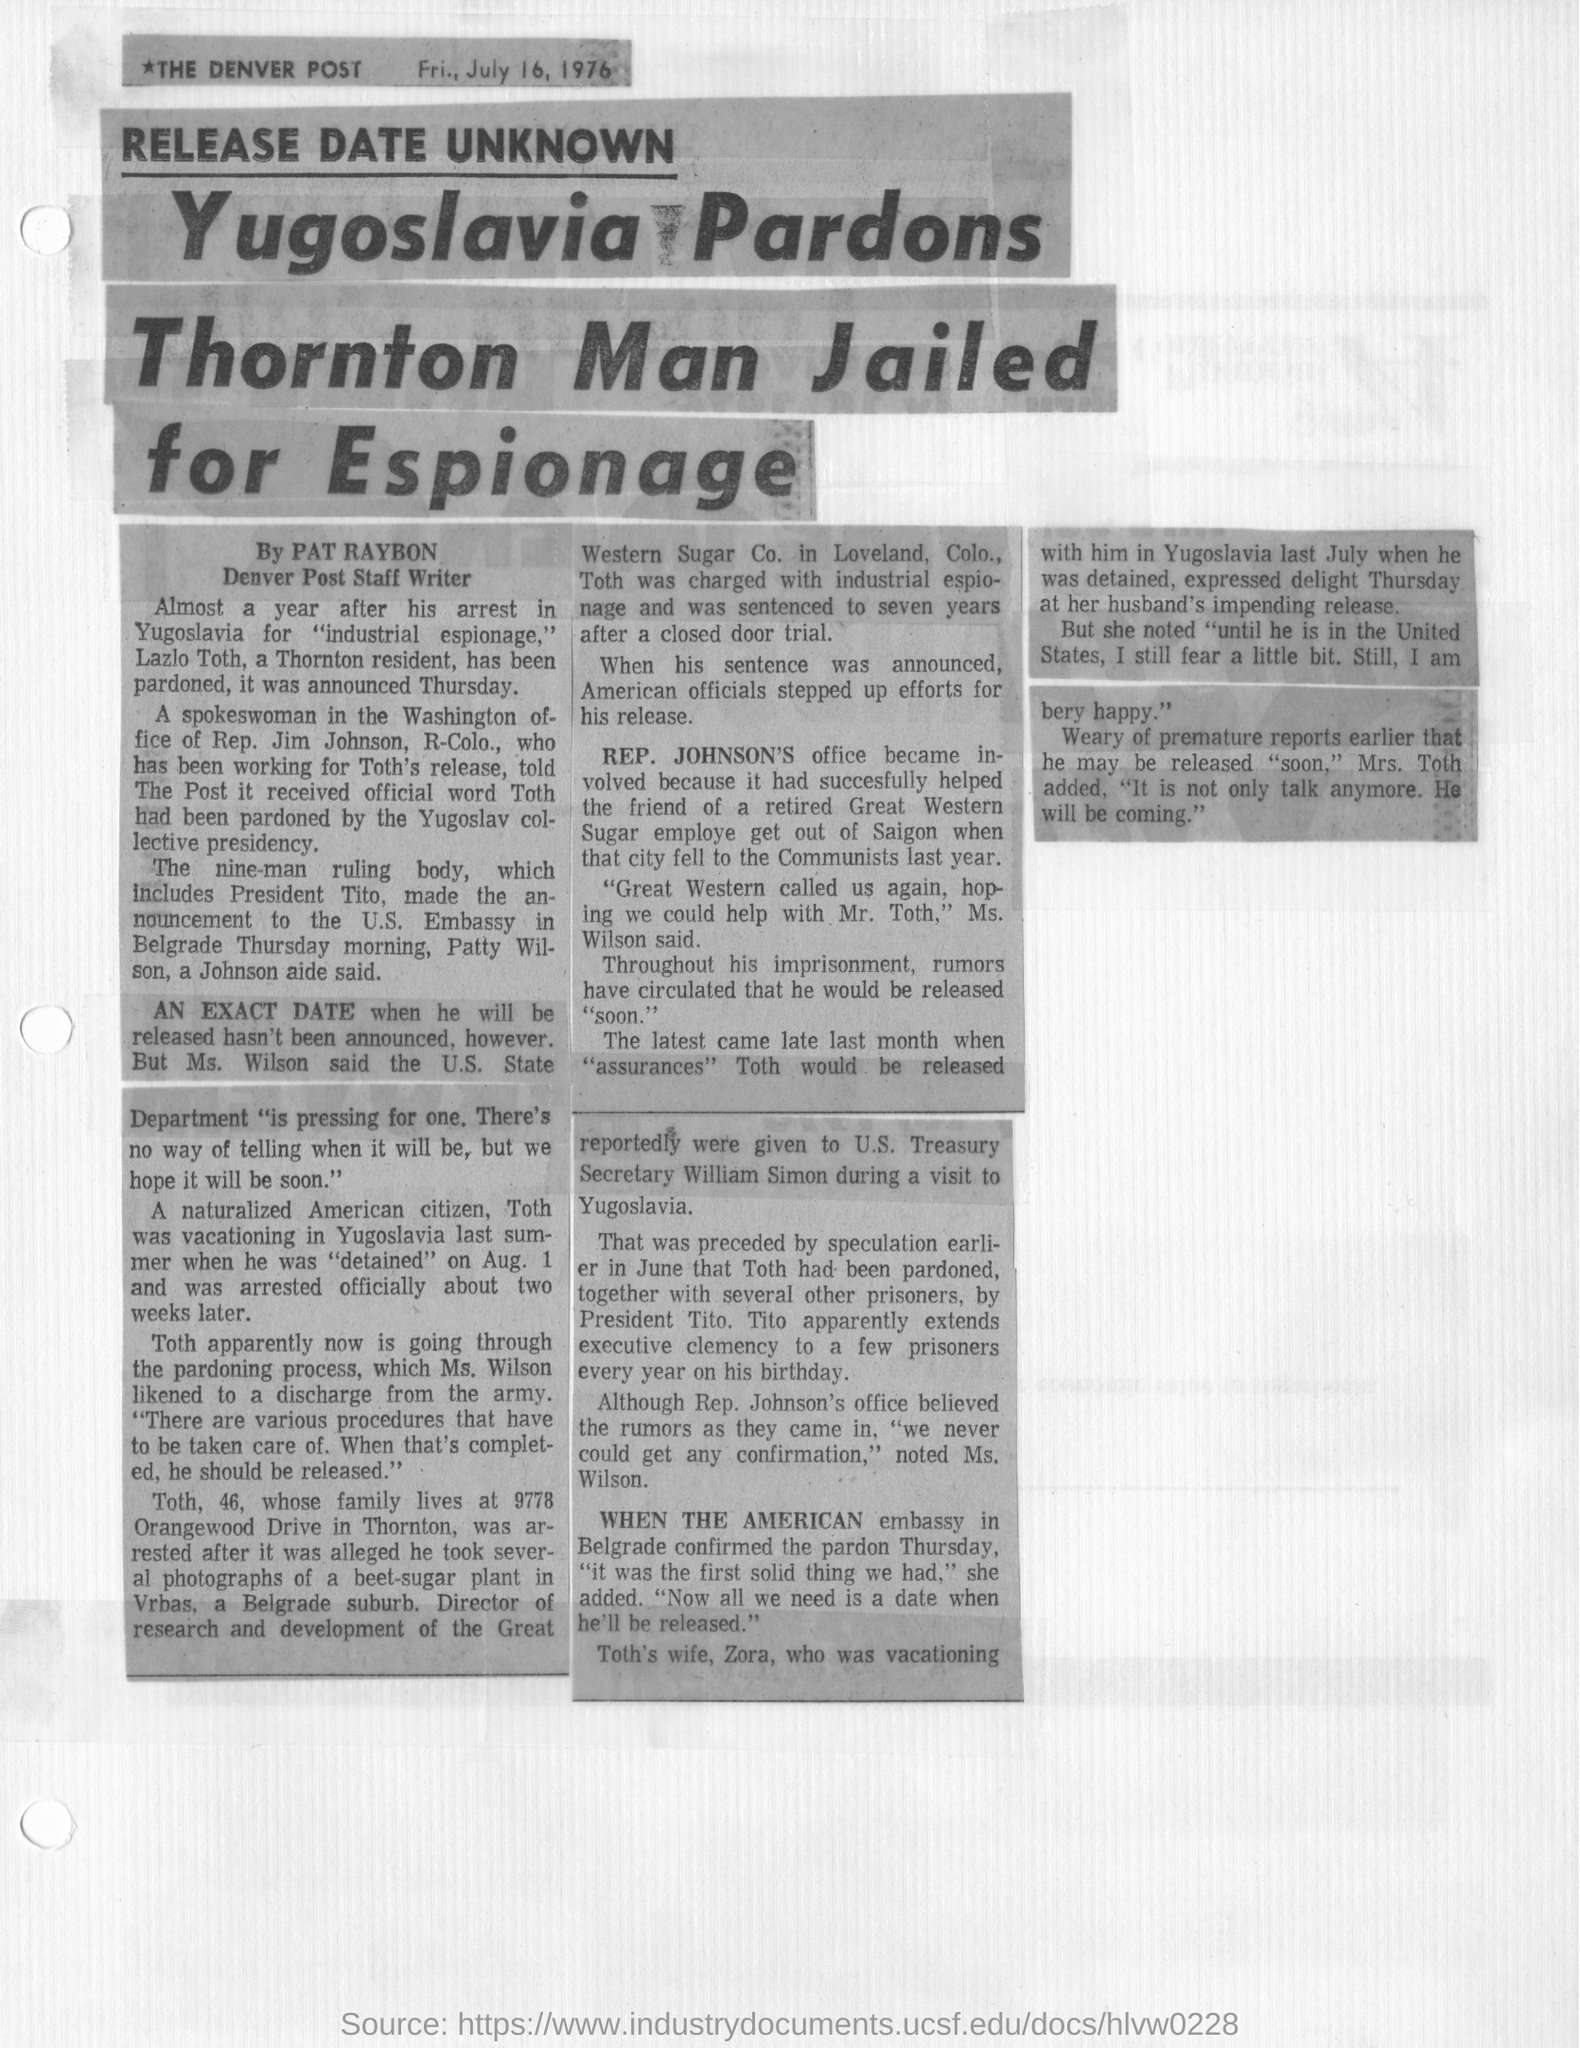Mention a couple of crucial points in this snapshot. The article was printed on July 16, 1976, on Friday. Lazlo Toth was arrested for the crime of industrial espionage. Yugoslavia has pardoned Lazlo Toth. The article is from THE DENVER POST newspaper. Lazlo Toth is a resident of Thornton, the town where he resides. 